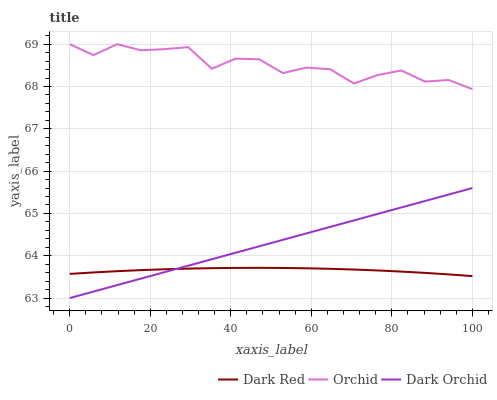Does Dark Red have the minimum area under the curve?
Answer yes or no. Yes. Does Orchid have the maximum area under the curve?
Answer yes or no. Yes. Does Dark Orchid have the minimum area under the curve?
Answer yes or no. No. Does Dark Orchid have the maximum area under the curve?
Answer yes or no. No. Is Dark Orchid the smoothest?
Answer yes or no. Yes. Is Orchid the roughest?
Answer yes or no. Yes. Is Orchid the smoothest?
Answer yes or no. No. Is Dark Orchid the roughest?
Answer yes or no. No. Does Dark Orchid have the lowest value?
Answer yes or no. Yes. Does Orchid have the lowest value?
Answer yes or no. No. Does Orchid have the highest value?
Answer yes or no. Yes. Does Dark Orchid have the highest value?
Answer yes or no. No. Is Dark Orchid less than Orchid?
Answer yes or no. Yes. Is Orchid greater than Dark Red?
Answer yes or no. Yes. Does Dark Orchid intersect Dark Red?
Answer yes or no. Yes. Is Dark Orchid less than Dark Red?
Answer yes or no. No. Is Dark Orchid greater than Dark Red?
Answer yes or no. No. Does Dark Orchid intersect Orchid?
Answer yes or no. No. 